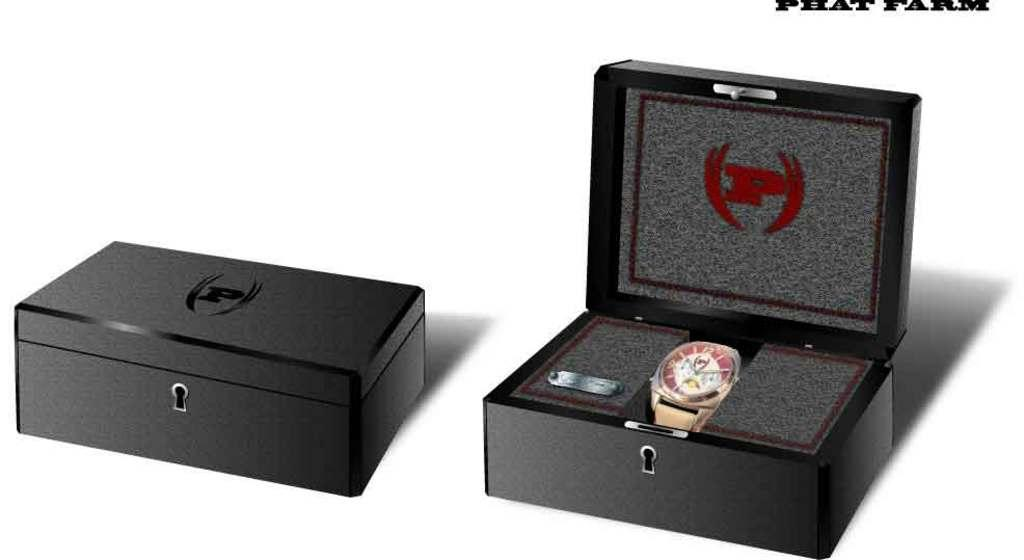<image>
Give a short and clear explanation of the subsequent image. Two boxes with the letter p and one box open with a watch inside 